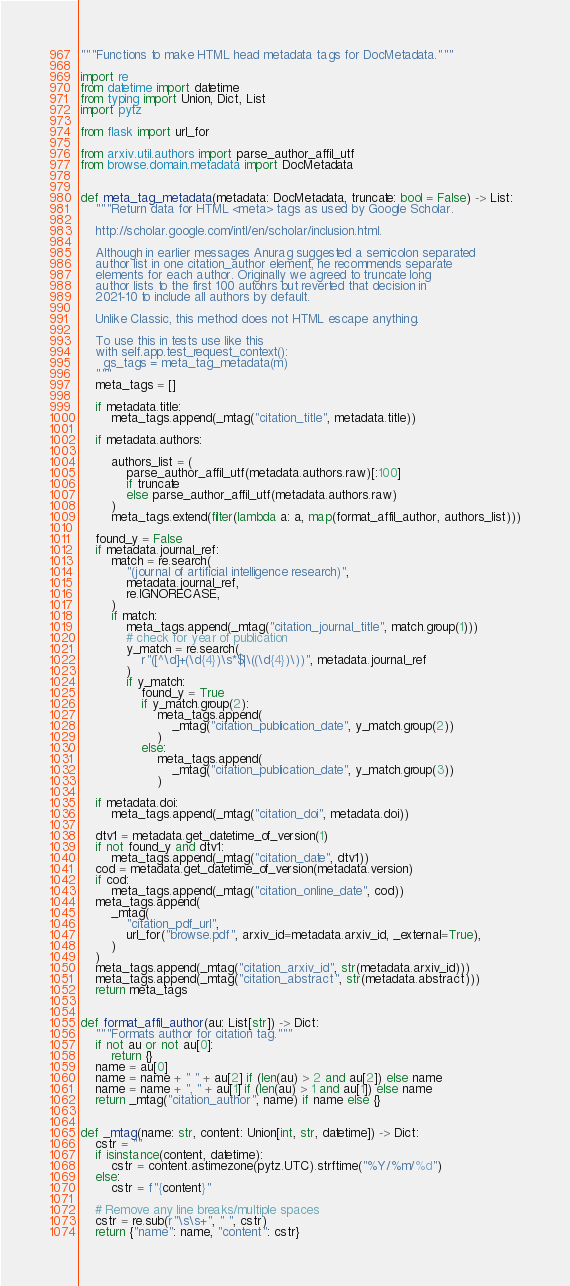<code> <loc_0><loc_0><loc_500><loc_500><_Python_>"""Functions to make HTML head metadata tags for DocMetadata."""

import re
from datetime import datetime
from typing import Union, Dict, List
import pytz

from flask import url_for

from arxiv.util.authors import parse_author_affil_utf
from browse.domain.metadata import DocMetadata


def meta_tag_metadata(metadata: DocMetadata, truncate: bool = False) -> List:
    """Return data for HTML <meta> tags as used by Google Scholar.

    http://scholar.google.com/intl/en/scholar/inclusion.html.

    Although in earlier messages Anurag suggested a semicolon separated
    author list in one citation_author element, he recommends separate
    elements for each author. Originally we agreed to truncate long
    author lists to the first 100 autohrs but reverted that decision in
    2021-10 to include all authors by default.

    Unlike Classic, this method does not HTML escape anything.

    To use this in tests use like this
    with self.app.test_request_context():
      gs_tags = meta_tag_metadata(m)
    """
    meta_tags = []

    if metadata.title:
        meta_tags.append(_mtag("citation_title", metadata.title))

    if metadata.authors:

        authors_list = (
            parse_author_affil_utf(metadata.authors.raw)[:100]
            if truncate
            else parse_author_affil_utf(metadata.authors.raw)
        )
        meta_tags.extend(filter(lambda a: a, map(format_affil_author, authors_list)))

    found_y = False
    if metadata.journal_ref:
        match = re.search(
            "(journal of artificial intelligence research)",
            metadata.journal_ref,
            re.IGNORECASE,
        )
        if match:
            meta_tags.append(_mtag("citation_journal_title", match.group(1)))
            # check for year of publication
            y_match = re.search(
                r"([^\d]+(\d{4})\s*$|\((\d{4})\))", metadata.journal_ref
            )
            if y_match:
                found_y = True
                if y_match.group(2):
                    meta_tags.append(
                        _mtag("citation_publication_date", y_match.group(2))
                    )
                else:
                    meta_tags.append(
                        _mtag("citation_publication_date", y_match.group(3))
                    )

    if metadata.doi:
        meta_tags.append(_mtag("citation_doi", metadata.doi))

    dtv1 = metadata.get_datetime_of_version(1)
    if not found_y and dtv1:
        meta_tags.append(_mtag("citation_date", dtv1))
    cod = metadata.get_datetime_of_version(metadata.version)
    if cod:
        meta_tags.append(_mtag("citation_online_date", cod))
    meta_tags.append(
        _mtag(
            "citation_pdf_url",
            url_for("browse.pdf", arxiv_id=metadata.arxiv_id, _external=True),
        )
    )
    meta_tags.append(_mtag("citation_arxiv_id", str(metadata.arxiv_id)))
    meta_tags.append(_mtag("citation_abstract", str(metadata.abstract)))
    return meta_tags


def format_affil_author(au: List[str]) -> Dict:
    """Formats author for citation tag."""
    if not au or not au[0]:
        return {}
    name = au[0]
    name = name + " " + au[2] if (len(au) > 2 and au[2]) else name
    name = name + ", " + au[1] if (len(au) > 1 and au[1]) else name
    return _mtag("citation_author", name) if name else {}


def _mtag(name: str, content: Union[int, str, datetime]) -> Dict:
    cstr = ""
    if isinstance(content, datetime):
        cstr = content.astimezone(pytz.UTC).strftime("%Y/%m/%d")
    else:
        cstr = f"{content}"

    # Remove any line breaks/multiple spaces
    cstr = re.sub(r"\s\s+", " ", cstr)
    return {"name": name, "content": cstr}
</code> 